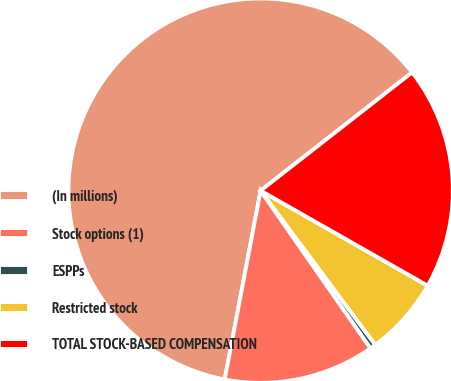Convert chart to OTSL. <chart><loc_0><loc_0><loc_500><loc_500><pie_chart><fcel>(In millions)<fcel>Stock options (1)<fcel>ESPPs<fcel>Restricted stock<fcel>TOTAL STOCK-BASED COMPENSATION<nl><fcel>61.46%<fcel>12.68%<fcel>0.49%<fcel>6.59%<fcel>18.78%<nl></chart> 